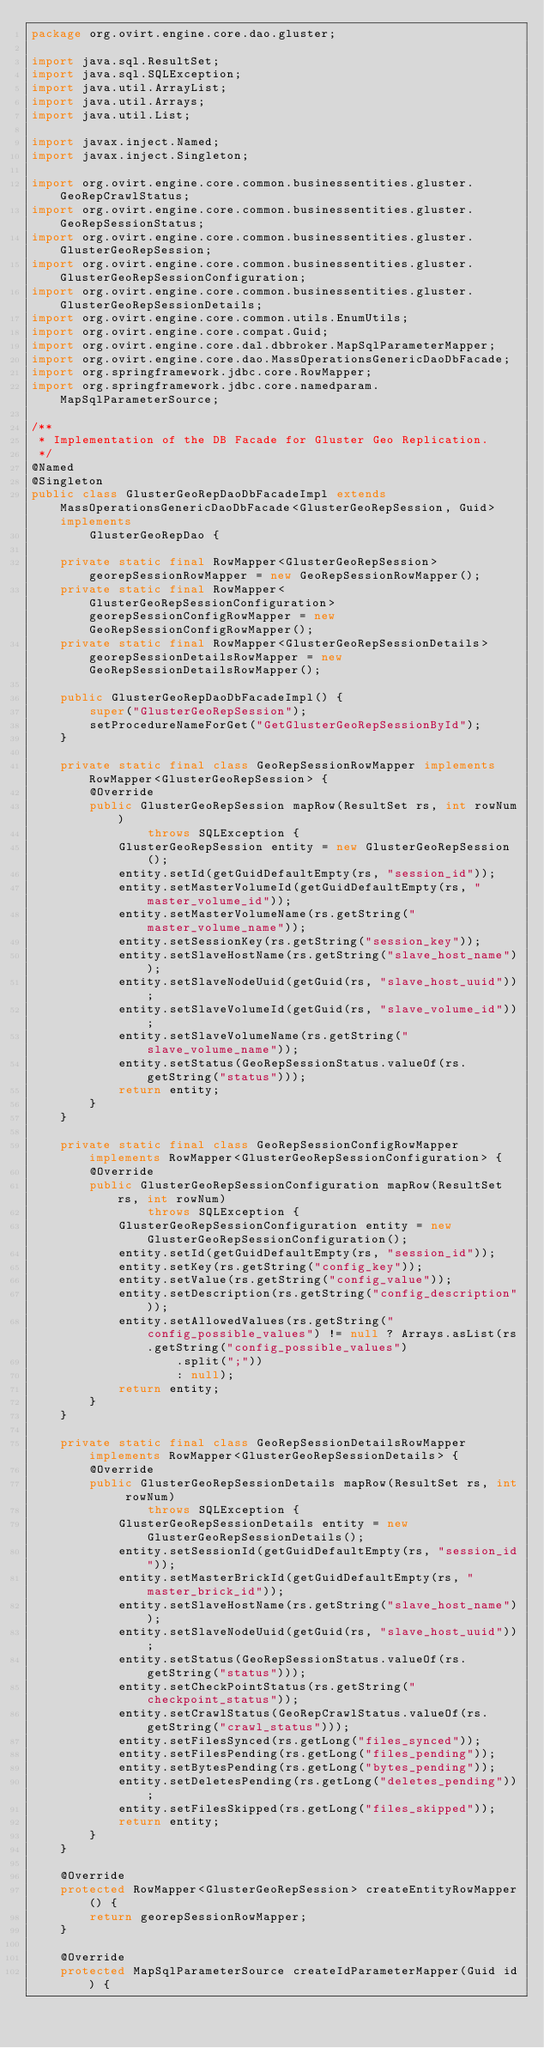Convert code to text. <code><loc_0><loc_0><loc_500><loc_500><_Java_>package org.ovirt.engine.core.dao.gluster;

import java.sql.ResultSet;
import java.sql.SQLException;
import java.util.ArrayList;
import java.util.Arrays;
import java.util.List;

import javax.inject.Named;
import javax.inject.Singleton;

import org.ovirt.engine.core.common.businessentities.gluster.GeoRepCrawlStatus;
import org.ovirt.engine.core.common.businessentities.gluster.GeoRepSessionStatus;
import org.ovirt.engine.core.common.businessentities.gluster.GlusterGeoRepSession;
import org.ovirt.engine.core.common.businessentities.gluster.GlusterGeoRepSessionConfiguration;
import org.ovirt.engine.core.common.businessentities.gluster.GlusterGeoRepSessionDetails;
import org.ovirt.engine.core.common.utils.EnumUtils;
import org.ovirt.engine.core.compat.Guid;
import org.ovirt.engine.core.dal.dbbroker.MapSqlParameterMapper;
import org.ovirt.engine.core.dao.MassOperationsGenericDaoDbFacade;
import org.springframework.jdbc.core.RowMapper;
import org.springframework.jdbc.core.namedparam.MapSqlParameterSource;

/**
 * Implementation of the DB Facade for Gluster Geo Replication.
 */
@Named
@Singleton
public class GlusterGeoRepDaoDbFacadeImpl extends MassOperationsGenericDaoDbFacade<GlusterGeoRepSession, Guid> implements
        GlusterGeoRepDao {

    private static final RowMapper<GlusterGeoRepSession> georepSessionRowMapper = new GeoRepSessionRowMapper();
    private static final RowMapper<GlusterGeoRepSessionConfiguration> georepSessionConfigRowMapper = new GeoRepSessionConfigRowMapper();
    private static final RowMapper<GlusterGeoRepSessionDetails> georepSessionDetailsRowMapper = new GeoRepSessionDetailsRowMapper();

    public GlusterGeoRepDaoDbFacadeImpl() {
        super("GlusterGeoRepSession");
        setProcedureNameForGet("GetGlusterGeoRepSessionById");
    }

    private static final class GeoRepSessionRowMapper implements RowMapper<GlusterGeoRepSession> {
        @Override
        public GlusterGeoRepSession mapRow(ResultSet rs, int rowNum)
                throws SQLException {
            GlusterGeoRepSession entity = new GlusterGeoRepSession();
            entity.setId(getGuidDefaultEmpty(rs, "session_id"));
            entity.setMasterVolumeId(getGuidDefaultEmpty(rs, "master_volume_id"));
            entity.setMasterVolumeName(rs.getString("master_volume_name"));
            entity.setSessionKey(rs.getString("session_key"));
            entity.setSlaveHostName(rs.getString("slave_host_name"));
            entity.setSlaveNodeUuid(getGuid(rs, "slave_host_uuid"));
            entity.setSlaveVolumeId(getGuid(rs, "slave_volume_id"));
            entity.setSlaveVolumeName(rs.getString("slave_volume_name"));
            entity.setStatus(GeoRepSessionStatus.valueOf(rs.getString("status")));
            return entity;
        }
    }

    private static final class GeoRepSessionConfigRowMapper implements RowMapper<GlusterGeoRepSessionConfiguration> {
        @Override
        public GlusterGeoRepSessionConfiguration mapRow(ResultSet rs, int rowNum)
                throws SQLException {
            GlusterGeoRepSessionConfiguration entity = new GlusterGeoRepSessionConfiguration();
            entity.setId(getGuidDefaultEmpty(rs, "session_id"));
            entity.setKey(rs.getString("config_key"));
            entity.setValue(rs.getString("config_value"));
            entity.setDescription(rs.getString("config_description"));
            entity.setAllowedValues(rs.getString("config_possible_values") != null ? Arrays.asList(rs.getString("config_possible_values")
                    .split(";"))
                    : null);
            return entity;
        }
    }

    private static final class GeoRepSessionDetailsRowMapper implements RowMapper<GlusterGeoRepSessionDetails> {
        @Override
        public GlusterGeoRepSessionDetails mapRow(ResultSet rs, int rowNum)
                throws SQLException {
            GlusterGeoRepSessionDetails entity = new GlusterGeoRepSessionDetails();
            entity.setSessionId(getGuidDefaultEmpty(rs, "session_id"));
            entity.setMasterBrickId(getGuidDefaultEmpty(rs, "master_brick_id"));
            entity.setSlaveHostName(rs.getString("slave_host_name"));
            entity.setSlaveNodeUuid(getGuid(rs, "slave_host_uuid"));
            entity.setStatus(GeoRepSessionStatus.valueOf(rs.getString("status")));
            entity.setCheckPointStatus(rs.getString("checkpoint_status"));
            entity.setCrawlStatus(GeoRepCrawlStatus.valueOf(rs.getString("crawl_status")));
            entity.setFilesSynced(rs.getLong("files_synced"));
            entity.setFilesPending(rs.getLong("files_pending"));
            entity.setBytesPending(rs.getLong("bytes_pending"));
            entity.setDeletesPending(rs.getLong("deletes_pending"));
            entity.setFilesSkipped(rs.getLong("files_skipped"));
            return entity;
        }
    }

    @Override
    protected RowMapper<GlusterGeoRepSession> createEntityRowMapper() {
        return georepSessionRowMapper;
    }

    @Override
    protected MapSqlParameterSource createIdParameterMapper(Guid id) {</code> 